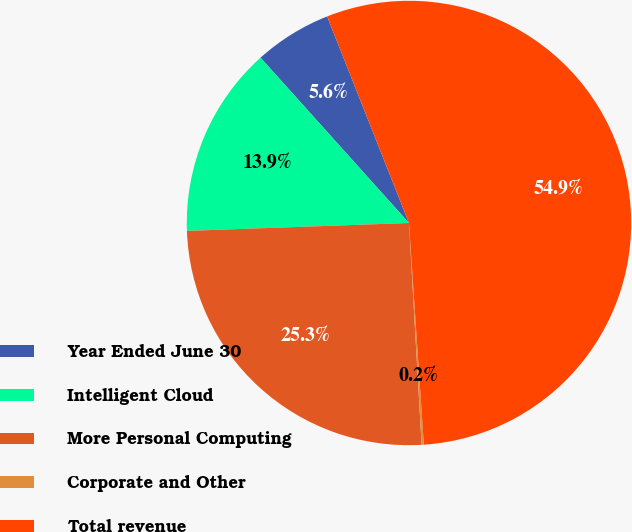<chart> <loc_0><loc_0><loc_500><loc_500><pie_chart><fcel>Year Ended June 30<fcel>Intelligent Cloud<fcel>More Personal Computing<fcel>Corporate and Other<fcel>Total revenue<nl><fcel>5.64%<fcel>13.92%<fcel>25.34%<fcel>0.16%<fcel>54.94%<nl></chart> 